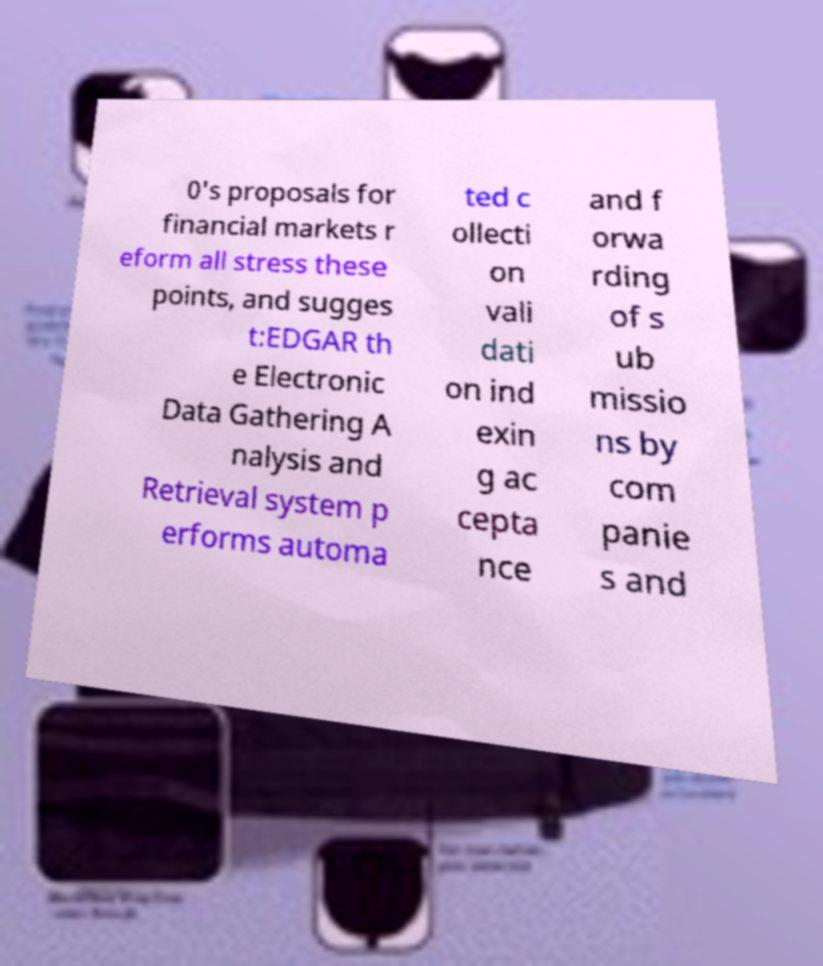I need the written content from this picture converted into text. Can you do that? 0's proposals for financial markets r eform all stress these points, and sugges t:EDGAR th e Electronic Data Gathering A nalysis and Retrieval system p erforms automa ted c ollecti on vali dati on ind exin g ac cepta nce and f orwa rding of s ub missio ns by com panie s and 